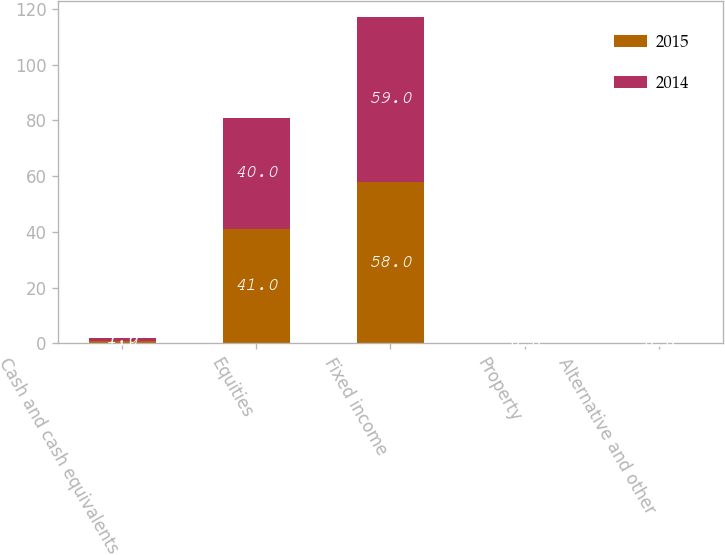<chart> <loc_0><loc_0><loc_500><loc_500><stacked_bar_chart><ecel><fcel>Cash and cash equivalents<fcel>Equities<fcel>Fixed income<fcel>Property<fcel>Alternative and other<nl><fcel>2015<fcel>1<fcel>41<fcel>58<fcel>0<fcel>0<nl><fcel>2014<fcel>1<fcel>40<fcel>59<fcel>0<fcel>0<nl></chart> 